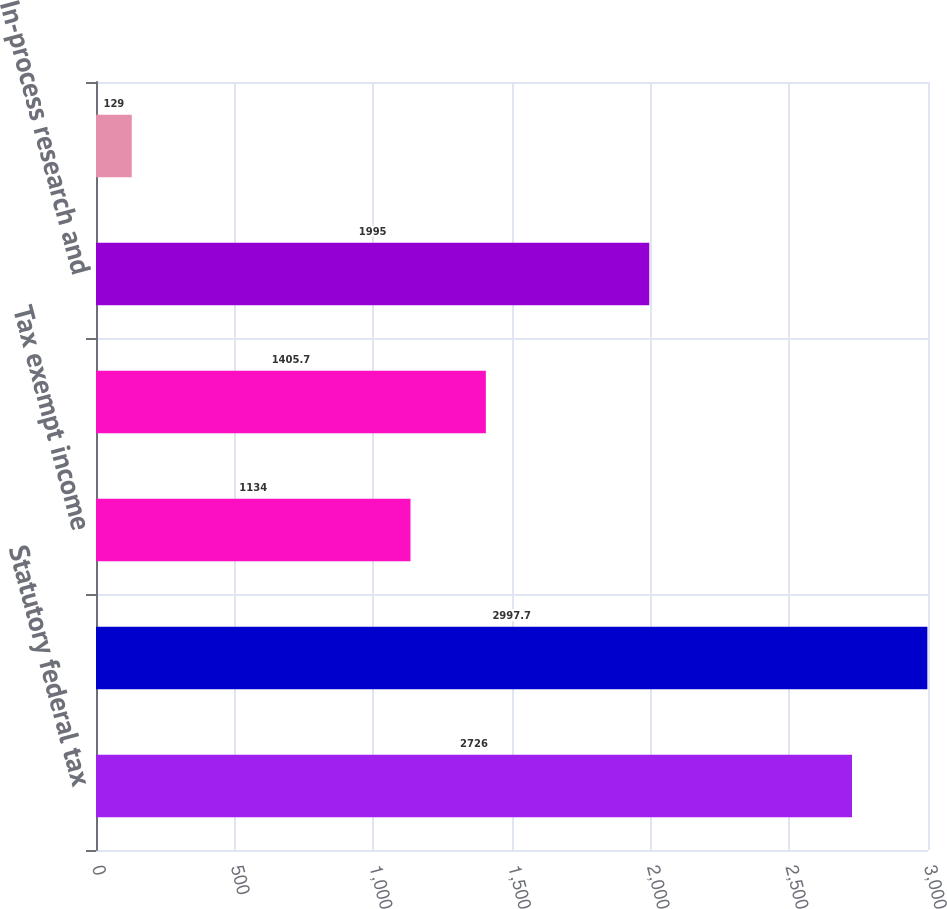Convert chart. <chart><loc_0><loc_0><loc_500><loc_500><bar_chart><fcel>Statutory federal tax<fcel>State tax net of federal<fcel>Tax exempt income<fcel>Foreign tax (less than) in<fcel>In-process research and<fcel>Other<nl><fcel>2726<fcel>2997.7<fcel>1134<fcel>1405.7<fcel>1995<fcel>129<nl></chart> 